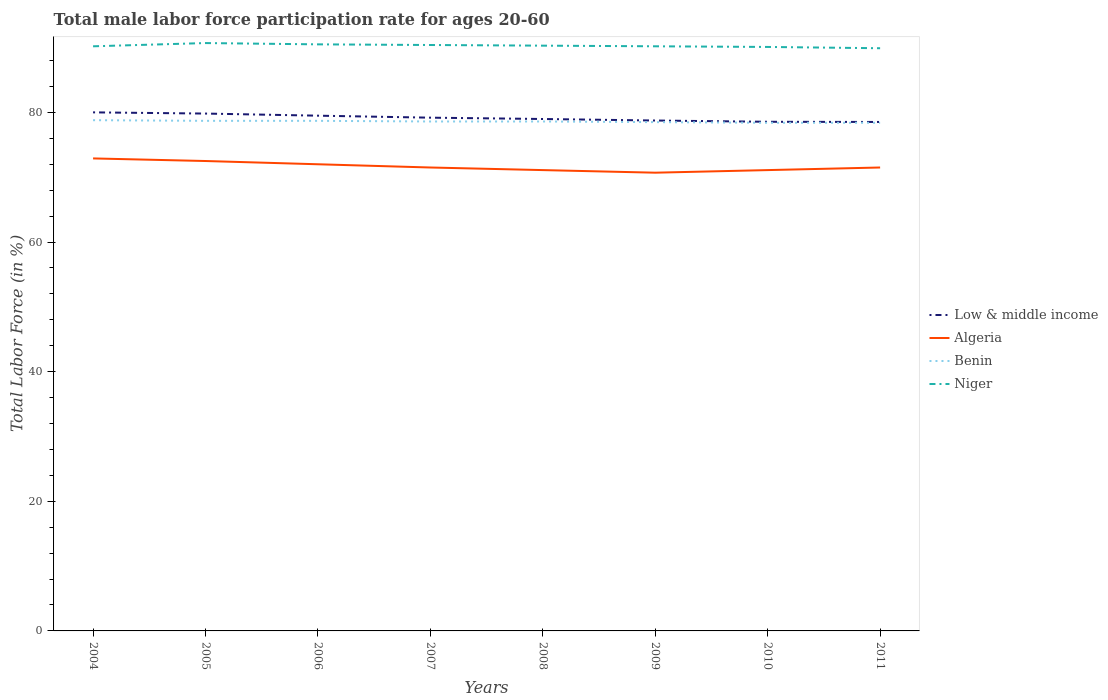Is the number of lines equal to the number of legend labels?
Offer a very short reply. Yes. Across all years, what is the maximum male labor force participation rate in Algeria?
Your answer should be very brief. 70.7. What is the total male labor force participation rate in Low & middle income in the graph?
Keep it short and to the point. 0.97. What is the difference between the highest and the second highest male labor force participation rate in Low & middle income?
Keep it short and to the point. 1.48. How many years are there in the graph?
Provide a succinct answer. 8. Are the values on the major ticks of Y-axis written in scientific E-notation?
Your response must be concise. No. Where does the legend appear in the graph?
Make the answer very short. Center right. How are the legend labels stacked?
Provide a short and direct response. Vertical. What is the title of the graph?
Offer a very short reply. Total male labor force participation rate for ages 20-60. What is the Total Labor Force (in %) of Low & middle income in 2004?
Offer a very short reply. 80.01. What is the Total Labor Force (in %) of Algeria in 2004?
Give a very brief answer. 72.9. What is the Total Labor Force (in %) in Benin in 2004?
Offer a very short reply. 78.8. What is the Total Labor Force (in %) in Niger in 2004?
Make the answer very short. 90.2. What is the Total Labor Force (in %) of Low & middle income in 2005?
Offer a terse response. 79.82. What is the Total Labor Force (in %) in Algeria in 2005?
Provide a short and direct response. 72.5. What is the Total Labor Force (in %) in Benin in 2005?
Offer a very short reply. 78.7. What is the Total Labor Force (in %) in Niger in 2005?
Offer a terse response. 90.7. What is the Total Labor Force (in %) of Low & middle income in 2006?
Make the answer very short. 79.5. What is the Total Labor Force (in %) of Algeria in 2006?
Provide a short and direct response. 72. What is the Total Labor Force (in %) of Benin in 2006?
Your response must be concise. 78.7. What is the Total Labor Force (in %) in Niger in 2006?
Give a very brief answer. 90.5. What is the Total Labor Force (in %) of Low & middle income in 2007?
Offer a terse response. 79.19. What is the Total Labor Force (in %) of Algeria in 2007?
Offer a terse response. 71.5. What is the Total Labor Force (in %) in Benin in 2007?
Ensure brevity in your answer.  78.6. What is the Total Labor Force (in %) of Niger in 2007?
Give a very brief answer. 90.4. What is the Total Labor Force (in %) of Low & middle income in 2008?
Provide a short and direct response. 78.98. What is the Total Labor Force (in %) of Algeria in 2008?
Your answer should be very brief. 71.1. What is the Total Labor Force (in %) in Benin in 2008?
Ensure brevity in your answer.  78.6. What is the Total Labor Force (in %) of Niger in 2008?
Your answer should be compact. 90.3. What is the Total Labor Force (in %) in Low & middle income in 2009?
Provide a succinct answer. 78.75. What is the Total Labor Force (in %) in Algeria in 2009?
Offer a very short reply. 70.7. What is the Total Labor Force (in %) in Benin in 2009?
Make the answer very short. 78.5. What is the Total Labor Force (in %) in Niger in 2009?
Offer a terse response. 90.2. What is the Total Labor Force (in %) of Low & middle income in 2010?
Give a very brief answer. 78.55. What is the Total Labor Force (in %) of Algeria in 2010?
Keep it short and to the point. 71.1. What is the Total Labor Force (in %) in Benin in 2010?
Your answer should be compact. 78.4. What is the Total Labor Force (in %) of Niger in 2010?
Your response must be concise. 90.1. What is the Total Labor Force (in %) of Low & middle income in 2011?
Make the answer very short. 78.53. What is the Total Labor Force (in %) in Algeria in 2011?
Ensure brevity in your answer.  71.5. What is the Total Labor Force (in %) in Benin in 2011?
Provide a short and direct response. 78.4. What is the Total Labor Force (in %) in Niger in 2011?
Give a very brief answer. 89.9. Across all years, what is the maximum Total Labor Force (in %) of Low & middle income?
Offer a terse response. 80.01. Across all years, what is the maximum Total Labor Force (in %) of Algeria?
Your response must be concise. 72.9. Across all years, what is the maximum Total Labor Force (in %) of Benin?
Offer a very short reply. 78.8. Across all years, what is the maximum Total Labor Force (in %) of Niger?
Your response must be concise. 90.7. Across all years, what is the minimum Total Labor Force (in %) of Low & middle income?
Your answer should be very brief. 78.53. Across all years, what is the minimum Total Labor Force (in %) in Algeria?
Keep it short and to the point. 70.7. Across all years, what is the minimum Total Labor Force (in %) of Benin?
Ensure brevity in your answer.  78.4. Across all years, what is the minimum Total Labor Force (in %) of Niger?
Make the answer very short. 89.9. What is the total Total Labor Force (in %) of Low & middle income in the graph?
Offer a terse response. 633.33. What is the total Total Labor Force (in %) of Algeria in the graph?
Offer a very short reply. 573.3. What is the total Total Labor Force (in %) of Benin in the graph?
Provide a succinct answer. 628.7. What is the total Total Labor Force (in %) in Niger in the graph?
Ensure brevity in your answer.  722.3. What is the difference between the Total Labor Force (in %) of Low & middle income in 2004 and that in 2005?
Offer a terse response. 0.19. What is the difference between the Total Labor Force (in %) in Low & middle income in 2004 and that in 2006?
Your answer should be compact. 0.51. What is the difference between the Total Labor Force (in %) in Low & middle income in 2004 and that in 2007?
Ensure brevity in your answer.  0.82. What is the difference between the Total Labor Force (in %) of Low & middle income in 2004 and that in 2008?
Give a very brief answer. 1.03. What is the difference between the Total Labor Force (in %) of Algeria in 2004 and that in 2008?
Your response must be concise. 1.8. What is the difference between the Total Labor Force (in %) of Benin in 2004 and that in 2008?
Give a very brief answer. 0.2. What is the difference between the Total Labor Force (in %) of Niger in 2004 and that in 2008?
Ensure brevity in your answer.  -0.1. What is the difference between the Total Labor Force (in %) of Low & middle income in 2004 and that in 2009?
Provide a short and direct response. 1.26. What is the difference between the Total Labor Force (in %) of Niger in 2004 and that in 2009?
Keep it short and to the point. 0. What is the difference between the Total Labor Force (in %) in Low & middle income in 2004 and that in 2010?
Keep it short and to the point. 1.45. What is the difference between the Total Labor Force (in %) of Benin in 2004 and that in 2010?
Make the answer very short. 0.4. What is the difference between the Total Labor Force (in %) of Niger in 2004 and that in 2010?
Keep it short and to the point. 0.1. What is the difference between the Total Labor Force (in %) in Low & middle income in 2004 and that in 2011?
Provide a succinct answer. 1.48. What is the difference between the Total Labor Force (in %) of Low & middle income in 2005 and that in 2006?
Your answer should be very brief. 0.33. What is the difference between the Total Labor Force (in %) in Algeria in 2005 and that in 2006?
Your response must be concise. 0.5. What is the difference between the Total Labor Force (in %) in Low & middle income in 2005 and that in 2007?
Make the answer very short. 0.63. What is the difference between the Total Labor Force (in %) of Algeria in 2005 and that in 2007?
Make the answer very short. 1. What is the difference between the Total Labor Force (in %) of Low & middle income in 2005 and that in 2008?
Give a very brief answer. 0.84. What is the difference between the Total Labor Force (in %) in Niger in 2005 and that in 2008?
Keep it short and to the point. 0.4. What is the difference between the Total Labor Force (in %) of Low & middle income in 2005 and that in 2009?
Keep it short and to the point. 1.07. What is the difference between the Total Labor Force (in %) in Low & middle income in 2005 and that in 2010?
Ensure brevity in your answer.  1.27. What is the difference between the Total Labor Force (in %) in Benin in 2005 and that in 2010?
Your response must be concise. 0.3. What is the difference between the Total Labor Force (in %) of Niger in 2005 and that in 2010?
Your response must be concise. 0.6. What is the difference between the Total Labor Force (in %) of Low & middle income in 2005 and that in 2011?
Ensure brevity in your answer.  1.3. What is the difference between the Total Labor Force (in %) of Benin in 2005 and that in 2011?
Ensure brevity in your answer.  0.3. What is the difference between the Total Labor Force (in %) of Niger in 2005 and that in 2011?
Offer a very short reply. 0.8. What is the difference between the Total Labor Force (in %) in Low & middle income in 2006 and that in 2007?
Provide a short and direct response. 0.31. What is the difference between the Total Labor Force (in %) of Benin in 2006 and that in 2007?
Offer a very short reply. 0.1. What is the difference between the Total Labor Force (in %) of Niger in 2006 and that in 2007?
Provide a succinct answer. 0.1. What is the difference between the Total Labor Force (in %) in Low & middle income in 2006 and that in 2008?
Your answer should be very brief. 0.51. What is the difference between the Total Labor Force (in %) in Algeria in 2006 and that in 2008?
Offer a very short reply. 0.9. What is the difference between the Total Labor Force (in %) of Benin in 2006 and that in 2008?
Offer a terse response. 0.1. What is the difference between the Total Labor Force (in %) in Low & middle income in 2006 and that in 2009?
Ensure brevity in your answer.  0.75. What is the difference between the Total Labor Force (in %) in Algeria in 2006 and that in 2009?
Your answer should be compact. 1.3. What is the difference between the Total Labor Force (in %) of Benin in 2006 and that in 2009?
Ensure brevity in your answer.  0.2. What is the difference between the Total Labor Force (in %) in Niger in 2006 and that in 2009?
Offer a terse response. 0.3. What is the difference between the Total Labor Force (in %) in Low & middle income in 2006 and that in 2010?
Provide a short and direct response. 0.94. What is the difference between the Total Labor Force (in %) of Benin in 2006 and that in 2010?
Offer a very short reply. 0.3. What is the difference between the Total Labor Force (in %) in Low & middle income in 2006 and that in 2011?
Offer a terse response. 0.97. What is the difference between the Total Labor Force (in %) in Algeria in 2006 and that in 2011?
Offer a very short reply. 0.5. What is the difference between the Total Labor Force (in %) of Benin in 2006 and that in 2011?
Provide a short and direct response. 0.3. What is the difference between the Total Labor Force (in %) in Low & middle income in 2007 and that in 2008?
Offer a very short reply. 0.2. What is the difference between the Total Labor Force (in %) in Algeria in 2007 and that in 2008?
Give a very brief answer. 0.4. What is the difference between the Total Labor Force (in %) of Niger in 2007 and that in 2008?
Your response must be concise. 0.1. What is the difference between the Total Labor Force (in %) in Low & middle income in 2007 and that in 2009?
Give a very brief answer. 0.44. What is the difference between the Total Labor Force (in %) of Algeria in 2007 and that in 2009?
Your answer should be very brief. 0.8. What is the difference between the Total Labor Force (in %) of Benin in 2007 and that in 2009?
Your answer should be very brief. 0.1. What is the difference between the Total Labor Force (in %) in Low & middle income in 2007 and that in 2010?
Offer a very short reply. 0.63. What is the difference between the Total Labor Force (in %) of Algeria in 2007 and that in 2010?
Keep it short and to the point. 0.4. What is the difference between the Total Labor Force (in %) of Benin in 2007 and that in 2010?
Give a very brief answer. 0.2. What is the difference between the Total Labor Force (in %) of Niger in 2007 and that in 2010?
Keep it short and to the point. 0.3. What is the difference between the Total Labor Force (in %) of Low & middle income in 2007 and that in 2011?
Your answer should be very brief. 0.66. What is the difference between the Total Labor Force (in %) of Low & middle income in 2008 and that in 2009?
Your response must be concise. 0.23. What is the difference between the Total Labor Force (in %) of Benin in 2008 and that in 2009?
Your answer should be compact. 0.1. What is the difference between the Total Labor Force (in %) of Niger in 2008 and that in 2009?
Your answer should be very brief. 0.1. What is the difference between the Total Labor Force (in %) of Low & middle income in 2008 and that in 2010?
Your answer should be very brief. 0.43. What is the difference between the Total Labor Force (in %) of Algeria in 2008 and that in 2010?
Your answer should be compact. 0. What is the difference between the Total Labor Force (in %) of Low & middle income in 2008 and that in 2011?
Provide a short and direct response. 0.46. What is the difference between the Total Labor Force (in %) in Niger in 2008 and that in 2011?
Offer a terse response. 0.4. What is the difference between the Total Labor Force (in %) in Low & middle income in 2009 and that in 2010?
Ensure brevity in your answer.  0.19. What is the difference between the Total Labor Force (in %) in Algeria in 2009 and that in 2010?
Your answer should be compact. -0.4. What is the difference between the Total Labor Force (in %) in Benin in 2009 and that in 2010?
Your answer should be compact. 0.1. What is the difference between the Total Labor Force (in %) of Low & middle income in 2009 and that in 2011?
Your answer should be very brief. 0.22. What is the difference between the Total Labor Force (in %) in Algeria in 2009 and that in 2011?
Keep it short and to the point. -0.8. What is the difference between the Total Labor Force (in %) of Benin in 2009 and that in 2011?
Offer a terse response. 0.1. What is the difference between the Total Labor Force (in %) of Niger in 2009 and that in 2011?
Keep it short and to the point. 0.3. What is the difference between the Total Labor Force (in %) of Low & middle income in 2010 and that in 2011?
Offer a terse response. 0.03. What is the difference between the Total Labor Force (in %) of Algeria in 2010 and that in 2011?
Offer a terse response. -0.4. What is the difference between the Total Labor Force (in %) of Benin in 2010 and that in 2011?
Your answer should be very brief. 0. What is the difference between the Total Labor Force (in %) of Low & middle income in 2004 and the Total Labor Force (in %) of Algeria in 2005?
Make the answer very short. 7.51. What is the difference between the Total Labor Force (in %) in Low & middle income in 2004 and the Total Labor Force (in %) in Benin in 2005?
Provide a short and direct response. 1.31. What is the difference between the Total Labor Force (in %) of Low & middle income in 2004 and the Total Labor Force (in %) of Niger in 2005?
Ensure brevity in your answer.  -10.69. What is the difference between the Total Labor Force (in %) of Algeria in 2004 and the Total Labor Force (in %) of Benin in 2005?
Your answer should be very brief. -5.8. What is the difference between the Total Labor Force (in %) of Algeria in 2004 and the Total Labor Force (in %) of Niger in 2005?
Offer a terse response. -17.8. What is the difference between the Total Labor Force (in %) of Low & middle income in 2004 and the Total Labor Force (in %) of Algeria in 2006?
Offer a terse response. 8.01. What is the difference between the Total Labor Force (in %) in Low & middle income in 2004 and the Total Labor Force (in %) in Benin in 2006?
Your answer should be very brief. 1.31. What is the difference between the Total Labor Force (in %) of Low & middle income in 2004 and the Total Labor Force (in %) of Niger in 2006?
Offer a terse response. -10.49. What is the difference between the Total Labor Force (in %) of Algeria in 2004 and the Total Labor Force (in %) of Benin in 2006?
Ensure brevity in your answer.  -5.8. What is the difference between the Total Labor Force (in %) in Algeria in 2004 and the Total Labor Force (in %) in Niger in 2006?
Offer a very short reply. -17.6. What is the difference between the Total Labor Force (in %) of Benin in 2004 and the Total Labor Force (in %) of Niger in 2006?
Ensure brevity in your answer.  -11.7. What is the difference between the Total Labor Force (in %) in Low & middle income in 2004 and the Total Labor Force (in %) in Algeria in 2007?
Give a very brief answer. 8.51. What is the difference between the Total Labor Force (in %) in Low & middle income in 2004 and the Total Labor Force (in %) in Benin in 2007?
Keep it short and to the point. 1.41. What is the difference between the Total Labor Force (in %) in Low & middle income in 2004 and the Total Labor Force (in %) in Niger in 2007?
Offer a terse response. -10.39. What is the difference between the Total Labor Force (in %) in Algeria in 2004 and the Total Labor Force (in %) in Niger in 2007?
Ensure brevity in your answer.  -17.5. What is the difference between the Total Labor Force (in %) in Low & middle income in 2004 and the Total Labor Force (in %) in Algeria in 2008?
Provide a short and direct response. 8.91. What is the difference between the Total Labor Force (in %) in Low & middle income in 2004 and the Total Labor Force (in %) in Benin in 2008?
Your answer should be very brief. 1.41. What is the difference between the Total Labor Force (in %) in Low & middle income in 2004 and the Total Labor Force (in %) in Niger in 2008?
Your answer should be compact. -10.29. What is the difference between the Total Labor Force (in %) in Algeria in 2004 and the Total Labor Force (in %) in Benin in 2008?
Your answer should be compact. -5.7. What is the difference between the Total Labor Force (in %) of Algeria in 2004 and the Total Labor Force (in %) of Niger in 2008?
Provide a short and direct response. -17.4. What is the difference between the Total Labor Force (in %) of Benin in 2004 and the Total Labor Force (in %) of Niger in 2008?
Give a very brief answer. -11.5. What is the difference between the Total Labor Force (in %) in Low & middle income in 2004 and the Total Labor Force (in %) in Algeria in 2009?
Give a very brief answer. 9.31. What is the difference between the Total Labor Force (in %) of Low & middle income in 2004 and the Total Labor Force (in %) of Benin in 2009?
Offer a terse response. 1.51. What is the difference between the Total Labor Force (in %) in Low & middle income in 2004 and the Total Labor Force (in %) in Niger in 2009?
Give a very brief answer. -10.19. What is the difference between the Total Labor Force (in %) of Algeria in 2004 and the Total Labor Force (in %) of Niger in 2009?
Offer a very short reply. -17.3. What is the difference between the Total Labor Force (in %) in Low & middle income in 2004 and the Total Labor Force (in %) in Algeria in 2010?
Offer a terse response. 8.91. What is the difference between the Total Labor Force (in %) in Low & middle income in 2004 and the Total Labor Force (in %) in Benin in 2010?
Offer a very short reply. 1.61. What is the difference between the Total Labor Force (in %) of Low & middle income in 2004 and the Total Labor Force (in %) of Niger in 2010?
Provide a succinct answer. -10.09. What is the difference between the Total Labor Force (in %) of Algeria in 2004 and the Total Labor Force (in %) of Benin in 2010?
Keep it short and to the point. -5.5. What is the difference between the Total Labor Force (in %) of Algeria in 2004 and the Total Labor Force (in %) of Niger in 2010?
Provide a succinct answer. -17.2. What is the difference between the Total Labor Force (in %) of Low & middle income in 2004 and the Total Labor Force (in %) of Algeria in 2011?
Provide a short and direct response. 8.51. What is the difference between the Total Labor Force (in %) in Low & middle income in 2004 and the Total Labor Force (in %) in Benin in 2011?
Ensure brevity in your answer.  1.61. What is the difference between the Total Labor Force (in %) of Low & middle income in 2004 and the Total Labor Force (in %) of Niger in 2011?
Ensure brevity in your answer.  -9.89. What is the difference between the Total Labor Force (in %) in Algeria in 2004 and the Total Labor Force (in %) in Benin in 2011?
Provide a short and direct response. -5.5. What is the difference between the Total Labor Force (in %) in Algeria in 2004 and the Total Labor Force (in %) in Niger in 2011?
Offer a terse response. -17. What is the difference between the Total Labor Force (in %) in Benin in 2004 and the Total Labor Force (in %) in Niger in 2011?
Offer a very short reply. -11.1. What is the difference between the Total Labor Force (in %) of Low & middle income in 2005 and the Total Labor Force (in %) of Algeria in 2006?
Give a very brief answer. 7.82. What is the difference between the Total Labor Force (in %) of Low & middle income in 2005 and the Total Labor Force (in %) of Benin in 2006?
Provide a short and direct response. 1.12. What is the difference between the Total Labor Force (in %) of Low & middle income in 2005 and the Total Labor Force (in %) of Niger in 2006?
Provide a succinct answer. -10.68. What is the difference between the Total Labor Force (in %) in Algeria in 2005 and the Total Labor Force (in %) in Niger in 2006?
Keep it short and to the point. -18. What is the difference between the Total Labor Force (in %) in Low & middle income in 2005 and the Total Labor Force (in %) in Algeria in 2007?
Provide a succinct answer. 8.32. What is the difference between the Total Labor Force (in %) in Low & middle income in 2005 and the Total Labor Force (in %) in Benin in 2007?
Your answer should be compact. 1.22. What is the difference between the Total Labor Force (in %) of Low & middle income in 2005 and the Total Labor Force (in %) of Niger in 2007?
Offer a terse response. -10.58. What is the difference between the Total Labor Force (in %) in Algeria in 2005 and the Total Labor Force (in %) in Benin in 2007?
Offer a very short reply. -6.1. What is the difference between the Total Labor Force (in %) in Algeria in 2005 and the Total Labor Force (in %) in Niger in 2007?
Make the answer very short. -17.9. What is the difference between the Total Labor Force (in %) of Benin in 2005 and the Total Labor Force (in %) of Niger in 2007?
Offer a very short reply. -11.7. What is the difference between the Total Labor Force (in %) in Low & middle income in 2005 and the Total Labor Force (in %) in Algeria in 2008?
Make the answer very short. 8.72. What is the difference between the Total Labor Force (in %) in Low & middle income in 2005 and the Total Labor Force (in %) in Benin in 2008?
Provide a succinct answer. 1.22. What is the difference between the Total Labor Force (in %) of Low & middle income in 2005 and the Total Labor Force (in %) of Niger in 2008?
Make the answer very short. -10.48. What is the difference between the Total Labor Force (in %) in Algeria in 2005 and the Total Labor Force (in %) in Niger in 2008?
Provide a succinct answer. -17.8. What is the difference between the Total Labor Force (in %) in Low & middle income in 2005 and the Total Labor Force (in %) in Algeria in 2009?
Keep it short and to the point. 9.12. What is the difference between the Total Labor Force (in %) in Low & middle income in 2005 and the Total Labor Force (in %) in Benin in 2009?
Ensure brevity in your answer.  1.32. What is the difference between the Total Labor Force (in %) in Low & middle income in 2005 and the Total Labor Force (in %) in Niger in 2009?
Your answer should be very brief. -10.38. What is the difference between the Total Labor Force (in %) of Algeria in 2005 and the Total Labor Force (in %) of Niger in 2009?
Make the answer very short. -17.7. What is the difference between the Total Labor Force (in %) in Benin in 2005 and the Total Labor Force (in %) in Niger in 2009?
Provide a short and direct response. -11.5. What is the difference between the Total Labor Force (in %) of Low & middle income in 2005 and the Total Labor Force (in %) of Algeria in 2010?
Your response must be concise. 8.72. What is the difference between the Total Labor Force (in %) in Low & middle income in 2005 and the Total Labor Force (in %) in Benin in 2010?
Make the answer very short. 1.42. What is the difference between the Total Labor Force (in %) of Low & middle income in 2005 and the Total Labor Force (in %) of Niger in 2010?
Give a very brief answer. -10.28. What is the difference between the Total Labor Force (in %) in Algeria in 2005 and the Total Labor Force (in %) in Niger in 2010?
Ensure brevity in your answer.  -17.6. What is the difference between the Total Labor Force (in %) in Benin in 2005 and the Total Labor Force (in %) in Niger in 2010?
Offer a very short reply. -11.4. What is the difference between the Total Labor Force (in %) of Low & middle income in 2005 and the Total Labor Force (in %) of Algeria in 2011?
Offer a terse response. 8.32. What is the difference between the Total Labor Force (in %) of Low & middle income in 2005 and the Total Labor Force (in %) of Benin in 2011?
Offer a very short reply. 1.42. What is the difference between the Total Labor Force (in %) in Low & middle income in 2005 and the Total Labor Force (in %) in Niger in 2011?
Provide a succinct answer. -10.08. What is the difference between the Total Labor Force (in %) of Algeria in 2005 and the Total Labor Force (in %) of Niger in 2011?
Keep it short and to the point. -17.4. What is the difference between the Total Labor Force (in %) of Low & middle income in 2006 and the Total Labor Force (in %) of Algeria in 2007?
Your answer should be compact. 8. What is the difference between the Total Labor Force (in %) of Low & middle income in 2006 and the Total Labor Force (in %) of Benin in 2007?
Offer a very short reply. 0.9. What is the difference between the Total Labor Force (in %) of Low & middle income in 2006 and the Total Labor Force (in %) of Niger in 2007?
Provide a succinct answer. -10.9. What is the difference between the Total Labor Force (in %) of Algeria in 2006 and the Total Labor Force (in %) of Benin in 2007?
Provide a succinct answer. -6.6. What is the difference between the Total Labor Force (in %) of Algeria in 2006 and the Total Labor Force (in %) of Niger in 2007?
Offer a terse response. -18.4. What is the difference between the Total Labor Force (in %) of Low & middle income in 2006 and the Total Labor Force (in %) of Algeria in 2008?
Ensure brevity in your answer.  8.4. What is the difference between the Total Labor Force (in %) in Low & middle income in 2006 and the Total Labor Force (in %) in Benin in 2008?
Your answer should be very brief. 0.9. What is the difference between the Total Labor Force (in %) in Low & middle income in 2006 and the Total Labor Force (in %) in Niger in 2008?
Ensure brevity in your answer.  -10.8. What is the difference between the Total Labor Force (in %) of Algeria in 2006 and the Total Labor Force (in %) of Benin in 2008?
Offer a terse response. -6.6. What is the difference between the Total Labor Force (in %) in Algeria in 2006 and the Total Labor Force (in %) in Niger in 2008?
Your response must be concise. -18.3. What is the difference between the Total Labor Force (in %) in Benin in 2006 and the Total Labor Force (in %) in Niger in 2008?
Your response must be concise. -11.6. What is the difference between the Total Labor Force (in %) of Low & middle income in 2006 and the Total Labor Force (in %) of Algeria in 2009?
Offer a terse response. 8.8. What is the difference between the Total Labor Force (in %) of Low & middle income in 2006 and the Total Labor Force (in %) of Niger in 2009?
Provide a short and direct response. -10.7. What is the difference between the Total Labor Force (in %) of Algeria in 2006 and the Total Labor Force (in %) of Benin in 2009?
Your answer should be compact. -6.5. What is the difference between the Total Labor Force (in %) in Algeria in 2006 and the Total Labor Force (in %) in Niger in 2009?
Give a very brief answer. -18.2. What is the difference between the Total Labor Force (in %) of Low & middle income in 2006 and the Total Labor Force (in %) of Algeria in 2010?
Your answer should be very brief. 8.4. What is the difference between the Total Labor Force (in %) of Low & middle income in 2006 and the Total Labor Force (in %) of Benin in 2010?
Your answer should be compact. 1.1. What is the difference between the Total Labor Force (in %) in Low & middle income in 2006 and the Total Labor Force (in %) in Niger in 2010?
Provide a succinct answer. -10.6. What is the difference between the Total Labor Force (in %) in Algeria in 2006 and the Total Labor Force (in %) in Niger in 2010?
Your response must be concise. -18.1. What is the difference between the Total Labor Force (in %) of Low & middle income in 2006 and the Total Labor Force (in %) of Algeria in 2011?
Your answer should be compact. 8. What is the difference between the Total Labor Force (in %) of Low & middle income in 2006 and the Total Labor Force (in %) of Benin in 2011?
Make the answer very short. 1.1. What is the difference between the Total Labor Force (in %) of Low & middle income in 2006 and the Total Labor Force (in %) of Niger in 2011?
Provide a short and direct response. -10.4. What is the difference between the Total Labor Force (in %) in Algeria in 2006 and the Total Labor Force (in %) in Niger in 2011?
Provide a succinct answer. -17.9. What is the difference between the Total Labor Force (in %) in Low & middle income in 2007 and the Total Labor Force (in %) in Algeria in 2008?
Keep it short and to the point. 8.09. What is the difference between the Total Labor Force (in %) of Low & middle income in 2007 and the Total Labor Force (in %) of Benin in 2008?
Offer a terse response. 0.59. What is the difference between the Total Labor Force (in %) of Low & middle income in 2007 and the Total Labor Force (in %) of Niger in 2008?
Offer a terse response. -11.11. What is the difference between the Total Labor Force (in %) of Algeria in 2007 and the Total Labor Force (in %) of Benin in 2008?
Offer a terse response. -7.1. What is the difference between the Total Labor Force (in %) of Algeria in 2007 and the Total Labor Force (in %) of Niger in 2008?
Offer a very short reply. -18.8. What is the difference between the Total Labor Force (in %) of Benin in 2007 and the Total Labor Force (in %) of Niger in 2008?
Provide a succinct answer. -11.7. What is the difference between the Total Labor Force (in %) in Low & middle income in 2007 and the Total Labor Force (in %) in Algeria in 2009?
Provide a short and direct response. 8.49. What is the difference between the Total Labor Force (in %) in Low & middle income in 2007 and the Total Labor Force (in %) in Benin in 2009?
Offer a very short reply. 0.69. What is the difference between the Total Labor Force (in %) of Low & middle income in 2007 and the Total Labor Force (in %) of Niger in 2009?
Keep it short and to the point. -11.01. What is the difference between the Total Labor Force (in %) of Algeria in 2007 and the Total Labor Force (in %) of Niger in 2009?
Ensure brevity in your answer.  -18.7. What is the difference between the Total Labor Force (in %) in Low & middle income in 2007 and the Total Labor Force (in %) in Algeria in 2010?
Offer a terse response. 8.09. What is the difference between the Total Labor Force (in %) of Low & middle income in 2007 and the Total Labor Force (in %) of Benin in 2010?
Your response must be concise. 0.79. What is the difference between the Total Labor Force (in %) in Low & middle income in 2007 and the Total Labor Force (in %) in Niger in 2010?
Your answer should be very brief. -10.91. What is the difference between the Total Labor Force (in %) of Algeria in 2007 and the Total Labor Force (in %) of Benin in 2010?
Provide a short and direct response. -6.9. What is the difference between the Total Labor Force (in %) of Algeria in 2007 and the Total Labor Force (in %) of Niger in 2010?
Your response must be concise. -18.6. What is the difference between the Total Labor Force (in %) of Benin in 2007 and the Total Labor Force (in %) of Niger in 2010?
Your answer should be compact. -11.5. What is the difference between the Total Labor Force (in %) in Low & middle income in 2007 and the Total Labor Force (in %) in Algeria in 2011?
Keep it short and to the point. 7.69. What is the difference between the Total Labor Force (in %) in Low & middle income in 2007 and the Total Labor Force (in %) in Benin in 2011?
Your response must be concise. 0.79. What is the difference between the Total Labor Force (in %) in Low & middle income in 2007 and the Total Labor Force (in %) in Niger in 2011?
Provide a short and direct response. -10.71. What is the difference between the Total Labor Force (in %) of Algeria in 2007 and the Total Labor Force (in %) of Benin in 2011?
Ensure brevity in your answer.  -6.9. What is the difference between the Total Labor Force (in %) in Algeria in 2007 and the Total Labor Force (in %) in Niger in 2011?
Offer a very short reply. -18.4. What is the difference between the Total Labor Force (in %) in Benin in 2007 and the Total Labor Force (in %) in Niger in 2011?
Give a very brief answer. -11.3. What is the difference between the Total Labor Force (in %) in Low & middle income in 2008 and the Total Labor Force (in %) in Algeria in 2009?
Your answer should be compact. 8.28. What is the difference between the Total Labor Force (in %) of Low & middle income in 2008 and the Total Labor Force (in %) of Benin in 2009?
Keep it short and to the point. 0.48. What is the difference between the Total Labor Force (in %) of Low & middle income in 2008 and the Total Labor Force (in %) of Niger in 2009?
Provide a succinct answer. -11.22. What is the difference between the Total Labor Force (in %) of Algeria in 2008 and the Total Labor Force (in %) of Benin in 2009?
Offer a terse response. -7.4. What is the difference between the Total Labor Force (in %) in Algeria in 2008 and the Total Labor Force (in %) in Niger in 2009?
Provide a short and direct response. -19.1. What is the difference between the Total Labor Force (in %) of Low & middle income in 2008 and the Total Labor Force (in %) of Algeria in 2010?
Provide a succinct answer. 7.88. What is the difference between the Total Labor Force (in %) of Low & middle income in 2008 and the Total Labor Force (in %) of Benin in 2010?
Give a very brief answer. 0.58. What is the difference between the Total Labor Force (in %) in Low & middle income in 2008 and the Total Labor Force (in %) in Niger in 2010?
Offer a terse response. -11.12. What is the difference between the Total Labor Force (in %) of Benin in 2008 and the Total Labor Force (in %) of Niger in 2010?
Provide a short and direct response. -11.5. What is the difference between the Total Labor Force (in %) in Low & middle income in 2008 and the Total Labor Force (in %) in Algeria in 2011?
Ensure brevity in your answer.  7.48. What is the difference between the Total Labor Force (in %) of Low & middle income in 2008 and the Total Labor Force (in %) of Benin in 2011?
Offer a terse response. 0.58. What is the difference between the Total Labor Force (in %) in Low & middle income in 2008 and the Total Labor Force (in %) in Niger in 2011?
Provide a short and direct response. -10.92. What is the difference between the Total Labor Force (in %) of Algeria in 2008 and the Total Labor Force (in %) of Benin in 2011?
Your response must be concise. -7.3. What is the difference between the Total Labor Force (in %) of Algeria in 2008 and the Total Labor Force (in %) of Niger in 2011?
Offer a terse response. -18.8. What is the difference between the Total Labor Force (in %) in Benin in 2008 and the Total Labor Force (in %) in Niger in 2011?
Make the answer very short. -11.3. What is the difference between the Total Labor Force (in %) in Low & middle income in 2009 and the Total Labor Force (in %) in Algeria in 2010?
Ensure brevity in your answer.  7.65. What is the difference between the Total Labor Force (in %) in Low & middle income in 2009 and the Total Labor Force (in %) in Benin in 2010?
Your answer should be very brief. 0.35. What is the difference between the Total Labor Force (in %) of Low & middle income in 2009 and the Total Labor Force (in %) of Niger in 2010?
Your response must be concise. -11.35. What is the difference between the Total Labor Force (in %) of Algeria in 2009 and the Total Labor Force (in %) of Niger in 2010?
Ensure brevity in your answer.  -19.4. What is the difference between the Total Labor Force (in %) in Benin in 2009 and the Total Labor Force (in %) in Niger in 2010?
Provide a succinct answer. -11.6. What is the difference between the Total Labor Force (in %) in Low & middle income in 2009 and the Total Labor Force (in %) in Algeria in 2011?
Provide a short and direct response. 7.25. What is the difference between the Total Labor Force (in %) of Low & middle income in 2009 and the Total Labor Force (in %) of Benin in 2011?
Offer a very short reply. 0.35. What is the difference between the Total Labor Force (in %) in Low & middle income in 2009 and the Total Labor Force (in %) in Niger in 2011?
Offer a very short reply. -11.15. What is the difference between the Total Labor Force (in %) of Algeria in 2009 and the Total Labor Force (in %) of Benin in 2011?
Your response must be concise. -7.7. What is the difference between the Total Labor Force (in %) of Algeria in 2009 and the Total Labor Force (in %) of Niger in 2011?
Provide a short and direct response. -19.2. What is the difference between the Total Labor Force (in %) of Benin in 2009 and the Total Labor Force (in %) of Niger in 2011?
Keep it short and to the point. -11.4. What is the difference between the Total Labor Force (in %) of Low & middle income in 2010 and the Total Labor Force (in %) of Algeria in 2011?
Offer a terse response. 7.05. What is the difference between the Total Labor Force (in %) in Low & middle income in 2010 and the Total Labor Force (in %) in Benin in 2011?
Provide a short and direct response. 0.15. What is the difference between the Total Labor Force (in %) of Low & middle income in 2010 and the Total Labor Force (in %) of Niger in 2011?
Your response must be concise. -11.35. What is the difference between the Total Labor Force (in %) of Algeria in 2010 and the Total Labor Force (in %) of Benin in 2011?
Your answer should be very brief. -7.3. What is the difference between the Total Labor Force (in %) in Algeria in 2010 and the Total Labor Force (in %) in Niger in 2011?
Provide a succinct answer. -18.8. What is the average Total Labor Force (in %) of Low & middle income per year?
Your response must be concise. 79.17. What is the average Total Labor Force (in %) in Algeria per year?
Your answer should be compact. 71.66. What is the average Total Labor Force (in %) of Benin per year?
Offer a very short reply. 78.59. What is the average Total Labor Force (in %) in Niger per year?
Make the answer very short. 90.29. In the year 2004, what is the difference between the Total Labor Force (in %) in Low & middle income and Total Labor Force (in %) in Algeria?
Your answer should be very brief. 7.11. In the year 2004, what is the difference between the Total Labor Force (in %) in Low & middle income and Total Labor Force (in %) in Benin?
Offer a terse response. 1.21. In the year 2004, what is the difference between the Total Labor Force (in %) of Low & middle income and Total Labor Force (in %) of Niger?
Keep it short and to the point. -10.19. In the year 2004, what is the difference between the Total Labor Force (in %) of Algeria and Total Labor Force (in %) of Benin?
Your answer should be compact. -5.9. In the year 2004, what is the difference between the Total Labor Force (in %) in Algeria and Total Labor Force (in %) in Niger?
Give a very brief answer. -17.3. In the year 2005, what is the difference between the Total Labor Force (in %) in Low & middle income and Total Labor Force (in %) in Algeria?
Your answer should be compact. 7.32. In the year 2005, what is the difference between the Total Labor Force (in %) of Low & middle income and Total Labor Force (in %) of Benin?
Offer a terse response. 1.12. In the year 2005, what is the difference between the Total Labor Force (in %) in Low & middle income and Total Labor Force (in %) in Niger?
Keep it short and to the point. -10.88. In the year 2005, what is the difference between the Total Labor Force (in %) in Algeria and Total Labor Force (in %) in Benin?
Your answer should be compact. -6.2. In the year 2005, what is the difference between the Total Labor Force (in %) in Algeria and Total Labor Force (in %) in Niger?
Keep it short and to the point. -18.2. In the year 2005, what is the difference between the Total Labor Force (in %) of Benin and Total Labor Force (in %) of Niger?
Ensure brevity in your answer.  -12. In the year 2006, what is the difference between the Total Labor Force (in %) of Low & middle income and Total Labor Force (in %) of Algeria?
Offer a very short reply. 7.5. In the year 2006, what is the difference between the Total Labor Force (in %) of Low & middle income and Total Labor Force (in %) of Benin?
Your answer should be very brief. 0.8. In the year 2006, what is the difference between the Total Labor Force (in %) of Low & middle income and Total Labor Force (in %) of Niger?
Provide a succinct answer. -11. In the year 2006, what is the difference between the Total Labor Force (in %) of Algeria and Total Labor Force (in %) of Benin?
Keep it short and to the point. -6.7. In the year 2006, what is the difference between the Total Labor Force (in %) of Algeria and Total Labor Force (in %) of Niger?
Keep it short and to the point. -18.5. In the year 2006, what is the difference between the Total Labor Force (in %) of Benin and Total Labor Force (in %) of Niger?
Your answer should be very brief. -11.8. In the year 2007, what is the difference between the Total Labor Force (in %) of Low & middle income and Total Labor Force (in %) of Algeria?
Offer a very short reply. 7.69. In the year 2007, what is the difference between the Total Labor Force (in %) in Low & middle income and Total Labor Force (in %) in Benin?
Give a very brief answer. 0.59. In the year 2007, what is the difference between the Total Labor Force (in %) of Low & middle income and Total Labor Force (in %) of Niger?
Keep it short and to the point. -11.21. In the year 2007, what is the difference between the Total Labor Force (in %) of Algeria and Total Labor Force (in %) of Niger?
Ensure brevity in your answer.  -18.9. In the year 2007, what is the difference between the Total Labor Force (in %) in Benin and Total Labor Force (in %) in Niger?
Offer a very short reply. -11.8. In the year 2008, what is the difference between the Total Labor Force (in %) of Low & middle income and Total Labor Force (in %) of Algeria?
Provide a short and direct response. 7.88. In the year 2008, what is the difference between the Total Labor Force (in %) in Low & middle income and Total Labor Force (in %) in Benin?
Your answer should be very brief. 0.38. In the year 2008, what is the difference between the Total Labor Force (in %) in Low & middle income and Total Labor Force (in %) in Niger?
Keep it short and to the point. -11.32. In the year 2008, what is the difference between the Total Labor Force (in %) in Algeria and Total Labor Force (in %) in Benin?
Ensure brevity in your answer.  -7.5. In the year 2008, what is the difference between the Total Labor Force (in %) in Algeria and Total Labor Force (in %) in Niger?
Ensure brevity in your answer.  -19.2. In the year 2009, what is the difference between the Total Labor Force (in %) in Low & middle income and Total Labor Force (in %) in Algeria?
Ensure brevity in your answer.  8.05. In the year 2009, what is the difference between the Total Labor Force (in %) of Low & middle income and Total Labor Force (in %) of Benin?
Offer a very short reply. 0.25. In the year 2009, what is the difference between the Total Labor Force (in %) of Low & middle income and Total Labor Force (in %) of Niger?
Provide a succinct answer. -11.45. In the year 2009, what is the difference between the Total Labor Force (in %) of Algeria and Total Labor Force (in %) of Niger?
Provide a succinct answer. -19.5. In the year 2009, what is the difference between the Total Labor Force (in %) in Benin and Total Labor Force (in %) in Niger?
Keep it short and to the point. -11.7. In the year 2010, what is the difference between the Total Labor Force (in %) of Low & middle income and Total Labor Force (in %) of Algeria?
Provide a short and direct response. 7.45. In the year 2010, what is the difference between the Total Labor Force (in %) in Low & middle income and Total Labor Force (in %) in Benin?
Provide a short and direct response. 0.15. In the year 2010, what is the difference between the Total Labor Force (in %) of Low & middle income and Total Labor Force (in %) of Niger?
Offer a very short reply. -11.55. In the year 2010, what is the difference between the Total Labor Force (in %) in Algeria and Total Labor Force (in %) in Benin?
Offer a very short reply. -7.3. In the year 2011, what is the difference between the Total Labor Force (in %) in Low & middle income and Total Labor Force (in %) in Algeria?
Keep it short and to the point. 7.03. In the year 2011, what is the difference between the Total Labor Force (in %) in Low & middle income and Total Labor Force (in %) in Benin?
Your response must be concise. 0.13. In the year 2011, what is the difference between the Total Labor Force (in %) in Low & middle income and Total Labor Force (in %) in Niger?
Keep it short and to the point. -11.37. In the year 2011, what is the difference between the Total Labor Force (in %) in Algeria and Total Labor Force (in %) in Niger?
Your response must be concise. -18.4. In the year 2011, what is the difference between the Total Labor Force (in %) in Benin and Total Labor Force (in %) in Niger?
Provide a short and direct response. -11.5. What is the ratio of the Total Labor Force (in %) of Low & middle income in 2004 to that in 2005?
Provide a short and direct response. 1. What is the ratio of the Total Labor Force (in %) in Algeria in 2004 to that in 2005?
Keep it short and to the point. 1.01. What is the ratio of the Total Labor Force (in %) in Low & middle income in 2004 to that in 2006?
Provide a short and direct response. 1.01. What is the ratio of the Total Labor Force (in %) in Algeria in 2004 to that in 2006?
Your answer should be very brief. 1.01. What is the ratio of the Total Labor Force (in %) in Low & middle income in 2004 to that in 2007?
Offer a terse response. 1.01. What is the ratio of the Total Labor Force (in %) in Algeria in 2004 to that in 2007?
Keep it short and to the point. 1.02. What is the ratio of the Total Labor Force (in %) in Benin in 2004 to that in 2007?
Offer a terse response. 1. What is the ratio of the Total Labor Force (in %) of Algeria in 2004 to that in 2008?
Offer a very short reply. 1.03. What is the ratio of the Total Labor Force (in %) of Benin in 2004 to that in 2008?
Provide a succinct answer. 1. What is the ratio of the Total Labor Force (in %) of Low & middle income in 2004 to that in 2009?
Your answer should be very brief. 1.02. What is the ratio of the Total Labor Force (in %) of Algeria in 2004 to that in 2009?
Provide a short and direct response. 1.03. What is the ratio of the Total Labor Force (in %) of Low & middle income in 2004 to that in 2010?
Give a very brief answer. 1.02. What is the ratio of the Total Labor Force (in %) in Algeria in 2004 to that in 2010?
Keep it short and to the point. 1.03. What is the ratio of the Total Labor Force (in %) of Low & middle income in 2004 to that in 2011?
Make the answer very short. 1.02. What is the ratio of the Total Labor Force (in %) of Algeria in 2004 to that in 2011?
Keep it short and to the point. 1.02. What is the ratio of the Total Labor Force (in %) in Niger in 2004 to that in 2011?
Your answer should be compact. 1. What is the ratio of the Total Labor Force (in %) in Low & middle income in 2005 to that in 2006?
Your answer should be compact. 1. What is the ratio of the Total Labor Force (in %) of Algeria in 2005 to that in 2007?
Give a very brief answer. 1.01. What is the ratio of the Total Labor Force (in %) of Benin in 2005 to that in 2007?
Your answer should be compact. 1. What is the ratio of the Total Labor Force (in %) of Low & middle income in 2005 to that in 2008?
Provide a short and direct response. 1.01. What is the ratio of the Total Labor Force (in %) in Algeria in 2005 to that in 2008?
Your answer should be very brief. 1.02. What is the ratio of the Total Labor Force (in %) of Low & middle income in 2005 to that in 2009?
Your answer should be very brief. 1.01. What is the ratio of the Total Labor Force (in %) of Algeria in 2005 to that in 2009?
Give a very brief answer. 1.03. What is the ratio of the Total Labor Force (in %) of Low & middle income in 2005 to that in 2010?
Give a very brief answer. 1.02. What is the ratio of the Total Labor Force (in %) in Algeria in 2005 to that in 2010?
Provide a succinct answer. 1.02. What is the ratio of the Total Labor Force (in %) of Niger in 2005 to that in 2010?
Offer a very short reply. 1.01. What is the ratio of the Total Labor Force (in %) of Low & middle income in 2005 to that in 2011?
Give a very brief answer. 1.02. What is the ratio of the Total Labor Force (in %) in Algeria in 2005 to that in 2011?
Offer a terse response. 1.01. What is the ratio of the Total Labor Force (in %) of Niger in 2005 to that in 2011?
Make the answer very short. 1.01. What is the ratio of the Total Labor Force (in %) of Algeria in 2006 to that in 2007?
Provide a succinct answer. 1.01. What is the ratio of the Total Labor Force (in %) of Niger in 2006 to that in 2007?
Provide a short and direct response. 1. What is the ratio of the Total Labor Force (in %) of Low & middle income in 2006 to that in 2008?
Give a very brief answer. 1.01. What is the ratio of the Total Labor Force (in %) in Algeria in 2006 to that in 2008?
Give a very brief answer. 1.01. What is the ratio of the Total Labor Force (in %) in Benin in 2006 to that in 2008?
Your answer should be very brief. 1. What is the ratio of the Total Labor Force (in %) of Low & middle income in 2006 to that in 2009?
Your answer should be very brief. 1.01. What is the ratio of the Total Labor Force (in %) in Algeria in 2006 to that in 2009?
Your answer should be compact. 1.02. What is the ratio of the Total Labor Force (in %) of Benin in 2006 to that in 2009?
Offer a terse response. 1. What is the ratio of the Total Labor Force (in %) in Niger in 2006 to that in 2009?
Your answer should be compact. 1. What is the ratio of the Total Labor Force (in %) in Algeria in 2006 to that in 2010?
Give a very brief answer. 1.01. What is the ratio of the Total Labor Force (in %) in Benin in 2006 to that in 2010?
Provide a succinct answer. 1. What is the ratio of the Total Labor Force (in %) in Low & middle income in 2006 to that in 2011?
Give a very brief answer. 1.01. What is the ratio of the Total Labor Force (in %) of Algeria in 2006 to that in 2011?
Your answer should be compact. 1.01. What is the ratio of the Total Labor Force (in %) of Low & middle income in 2007 to that in 2008?
Provide a succinct answer. 1. What is the ratio of the Total Labor Force (in %) in Algeria in 2007 to that in 2008?
Give a very brief answer. 1.01. What is the ratio of the Total Labor Force (in %) in Benin in 2007 to that in 2008?
Ensure brevity in your answer.  1. What is the ratio of the Total Labor Force (in %) of Low & middle income in 2007 to that in 2009?
Your answer should be very brief. 1.01. What is the ratio of the Total Labor Force (in %) in Algeria in 2007 to that in 2009?
Keep it short and to the point. 1.01. What is the ratio of the Total Labor Force (in %) of Algeria in 2007 to that in 2010?
Ensure brevity in your answer.  1.01. What is the ratio of the Total Labor Force (in %) of Niger in 2007 to that in 2010?
Offer a terse response. 1. What is the ratio of the Total Labor Force (in %) in Low & middle income in 2007 to that in 2011?
Ensure brevity in your answer.  1.01. What is the ratio of the Total Labor Force (in %) in Algeria in 2007 to that in 2011?
Your answer should be compact. 1. What is the ratio of the Total Labor Force (in %) in Niger in 2007 to that in 2011?
Offer a terse response. 1.01. What is the ratio of the Total Labor Force (in %) in Benin in 2008 to that in 2009?
Your answer should be very brief. 1. What is the ratio of the Total Labor Force (in %) in Algeria in 2008 to that in 2010?
Offer a very short reply. 1. What is the ratio of the Total Labor Force (in %) in Benin in 2008 to that in 2010?
Ensure brevity in your answer.  1. What is the ratio of the Total Labor Force (in %) in Niger in 2008 to that in 2010?
Provide a succinct answer. 1. What is the ratio of the Total Labor Force (in %) in Algeria in 2008 to that in 2011?
Your response must be concise. 0.99. What is the ratio of the Total Labor Force (in %) of Niger in 2008 to that in 2011?
Your response must be concise. 1. What is the ratio of the Total Labor Force (in %) of Low & middle income in 2009 to that in 2010?
Ensure brevity in your answer.  1. What is the ratio of the Total Labor Force (in %) of Benin in 2009 to that in 2010?
Make the answer very short. 1. What is the ratio of the Total Labor Force (in %) of Niger in 2009 to that in 2010?
Ensure brevity in your answer.  1. What is the ratio of the Total Labor Force (in %) of Algeria in 2009 to that in 2011?
Your answer should be compact. 0.99. What is the ratio of the Total Labor Force (in %) in Benin in 2009 to that in 2011?
Give a very brief answer. 1. What is the ratio of the Total Labor Force (in %) in Benin in 2010 to that in 2011?
Make the answer very short. 1. What is the ratio of the Total Labor Force (in %) of Niger in 2010 to that in 2011?
Give a very brief answer. 1. What is the difference between the highest and the second highest Total Labor Force (in %) in Low & middle income?
Provide a succinct answer. 0.19. What is the difference between the highest and the second highest Total Labor Force (in %) of Benin?
Offer a terse response. 0.1. What is the difference between the highest and the second highest Total Labor Force (in %) in Niger?
Give a very brief answer. 0.2. What is the difference between the highest and the lowest Total Labor Force (in %) of Low & middle income?
Offer a very short reply. 1.48. What is the difference between the highest and the lowest Total Labor Force (in %) of Niger?
Offer a terse response. 0.8. 